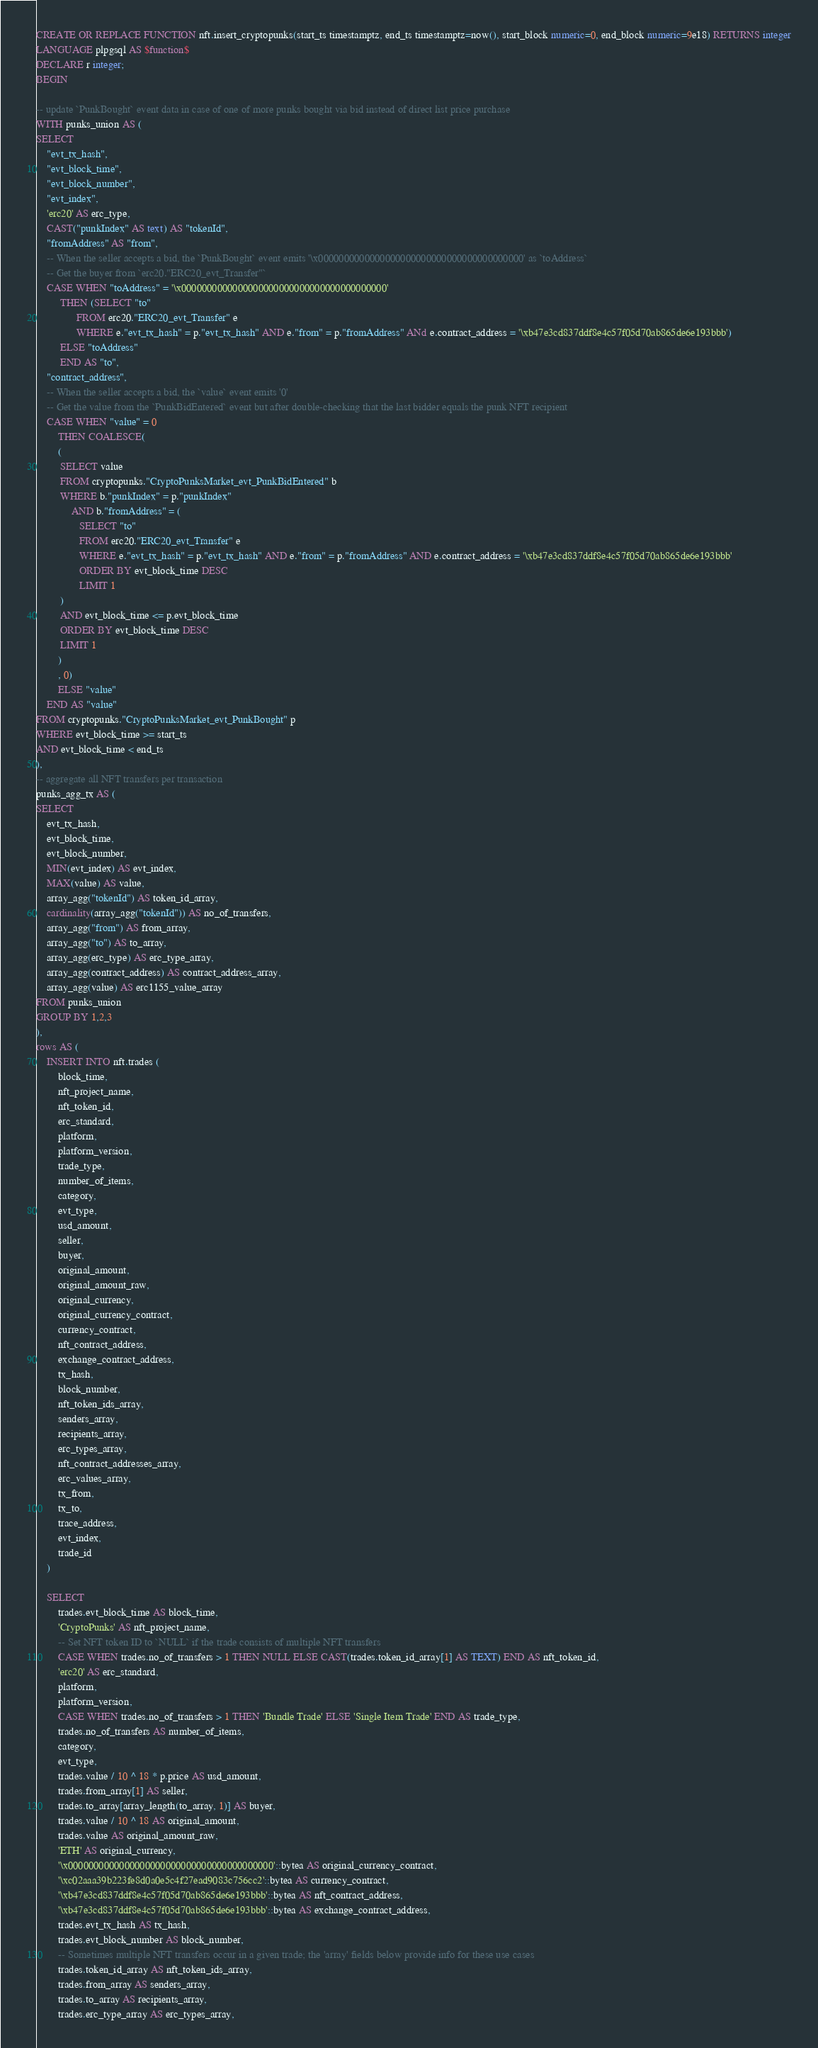<code> <loc_0><loc_0><loc_500><loc_500><_SQL_>CREATE OR REPLACE FUNCTION nft.insert_cryptopunks(start_ts timestamptz, end_ts timestamptz=now(), start_block numeric=0, end_block numeric=9e18) RETURNS integer
LANGUAGE plpgsql AS $function$
DECLARE r integer;
BEGIN

-- update `PunkBought` event data in case of one of more punks bought via bid instead of direct list price purchase
WITH punks_union AS (
SELECT
    "evt_tx_hash",
    "evt_block_time",
    "evt_block_number",
    "evt_index",
    'erc20' AS erc_type,
    CAST("punkIndex" AS text) AS "tokenId",
    "fromAddress" AS "from",
    -- When the seller accepts a bid, the `PunkBought` event emits '\x0000000000000000000000000000000000000000' as `toAddress`
    -- Get the buyer from `erc20."ERC20_evt_Transfer"`
    CASE WHEN "toAddress" = '\x0000000000000000000000000000000000000000'
         THEN (SELECT "to"
               FROM erc20."ERC20_evt_Transfer" e
               WHERE e."evt_tx_hash" = p."evt_tx_hash" AND e."from" = p."fromAddress" ANd e.contract_address = '\xb47e3cd837ddf8e4c57f05d70ab865de6e193bbb')
         ELSE "toAddress"
         END AS "to",
    "contract_address",
    -- When the seller accepts a bid, the `value` event emits '0'
    -- Get the value from the `PunkBidEntered` event but after double-checking that the last bidder equals the punk NFT recipient
    CASE WHEN "value" = 0
        THEN COALESCE(
        (
         SELECT value
         FROM cryptopunks."CryptoPunksMarket_evt_PunkBidEntered" b
         WHERE b."punkIndex" = p."punkIndex"
             AND b."fromAddress" = (
                SELECT "to"
                FROM erc20."ERC20_evt_Transfer" e
                WHERE e."evt_tx_hash" = p."evt_tx_hash" AND e."from" = p."fromAddress" AND e.contract_address = '\xb47e3cd837ddf8e4c57f05d70ab865de6e193bbb'
                ORDER BY evt_block_time DESC
                LIMIT 1
         )
         AND evt_block_time <= p.evt_block_time
         ORDER BY evt_block_time DESC
         LIMIT 1
        )
        , 0)
        ELSE "value"
    END AS "value"
FROM cryptopunks."CryptoPunksMarket_evt_PunkBought" p
WHERE evt_block_time >= start_ts
AND evt_block_time < end_ts
),
-- aggregate all NFT transfers per transaction
punks_agg_tx AS (
SELECT
    evt_tx_hash,
    evt_block_time,
    evt_block_number,
    MIN(evt_index) AS evt_index,
    MAX(value) AS value,
    array_agg("tokenId") AS token_id_array,
    cardinality(array_agg("tokenId")) AS no_of_transfers,
    array_agg("from") AS from_array,
    array_agg("to") AS to_array,
    array_agg(erc_type) AS erc_type_array,
    array_agg(contract_address) AS contract_address_array,
    array_agg(value) AS erc1155_value_array
FROM punks_union
GROUP BY 1,2,3
),
rows AS (
    INSERT INTO nft.trades (
        block_time,
        nft_project_name,
        nft_token_id,
        erc_standard,
        platform,
        platform_version,
        trade_type,
        number_of_items,
        category,
        evt_type,
        usd_amount,
        seller,
        buyer,
        original_amount,
        original_amount_raw,
        original_currency,
        original_currency_contract,
        currency_contract,
        nft_contract_address,
        exchange_contract_address,
        tx_hash,
        block_number,
        nft_token_ids_array,
        senders_array,
        recipients_array,
        erc_types_array,
        nft_contract_addresses_array,
        erc_values_array,
        tx_from,
        tx_to,
        trace_address,
        evt_index,
        trade_id
    )

    SELECT
        trades.evt_block_time AS block_time,
        'CryptoPunks' AS nft_project_name,
        -- Set NFT token ID to `NULL` if the trade consists of multiple NFT transfers
        CASE WHEN trades.no_of_transfers > 1 THEN NULL ELSE CAST(trades.token_id_array[1] AS TEXT) END AS nft_token_id,
        'erc20' AS erc_standard,
        platform,
        platform_version,
        CASE WHEN trades.no_of_transfers > 1 THEN 'Bundle Trade' ELSE 'Single Item Trade' END AS trade_type,
        trades.no_of_transfers AS number_of_items,
        category,
        evt_type,
        trades.value / 10 ^ 18 * p.price AS usd_amount,
        trades.from_array[1] AS seller,
        trades.to_array[array_length(to_array, 1)] AS buyer,
        trades.value / 10 ^ 18 AS original_amount,
        trades.value AS original_amount_raw,
        'ETH' AS original_currency,
        '\x0000000000000000000000000000000000000000'::bytea AS original_currency_contract,
        '\xc02aaa39b223fe8d0a0e5c4f27ead9083c756cc2'::bytea AS currency_contract,
        '\xb47e3cd837ddf8e4c57f05d70ab865de6e193bbb'::bytea AS nft_contract_address,
        '\xb47e3cd837ddf8e4c57f05d70ab865de6e193bbb'::bytea AS exchange_contract_address,
        trades.evt_tx_hash AS tx_hash,
        trades.evt_block_number AS block_number,
        -- Sometimes multiple NFT transfers occur in a given trade; the 'array' fields below provide info for these use cases
        trades.token_id_array AS nft_token_ids_array,
        trades.from_array AS senders_array,
        trades.to_array AS recipients_array,
        trades.erc_type_array AS erc_types_array,</code> 